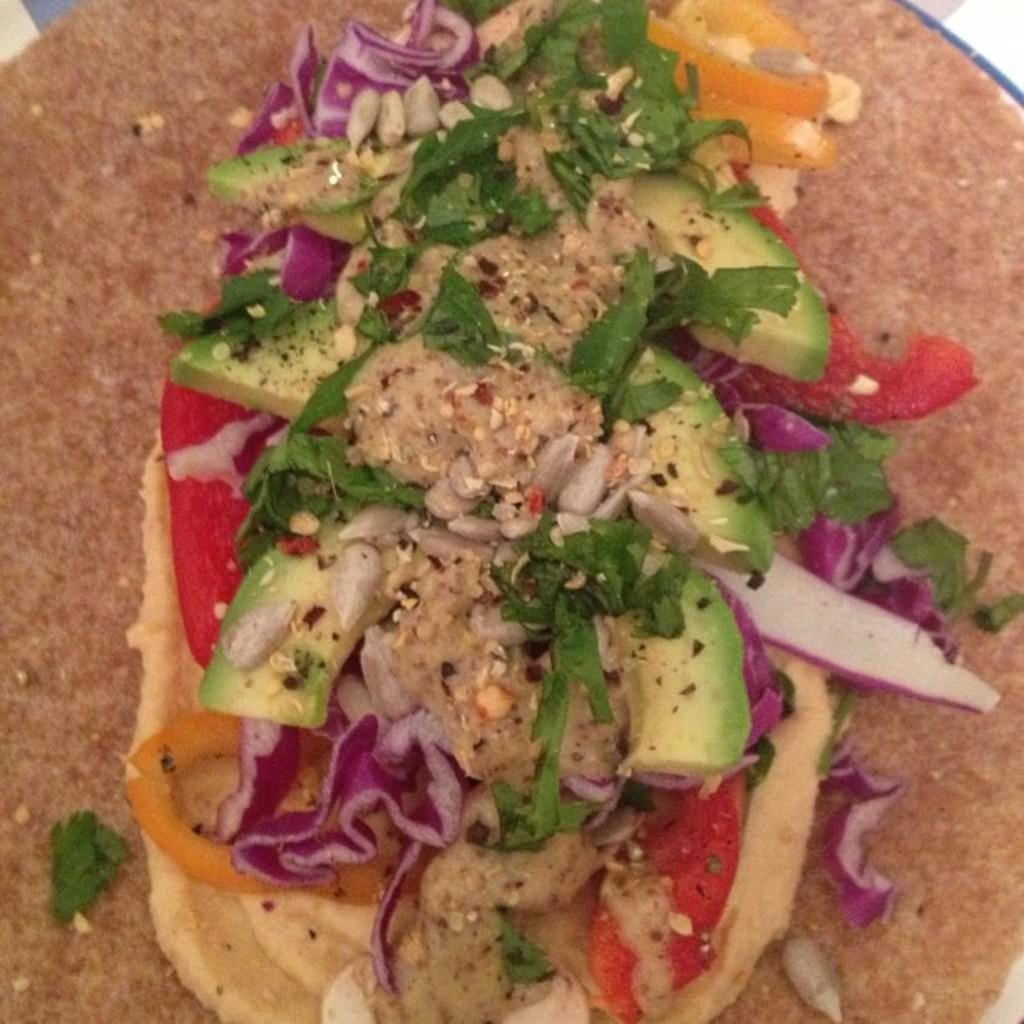What type of food can be seen in the image? There is food in the image, specifically red cabbage pieces and avocado pieces. Can you describe the appearance of the red cabbage pieces? The red cabbage pieces are visible in the image. What other type of food is present in the image besides red cabbage? There are avocado pieces in the image. What type of dress is the avocado wearing in the image? There is no dress present in the image, as the avocado is a type of food and not a person or animate object. 